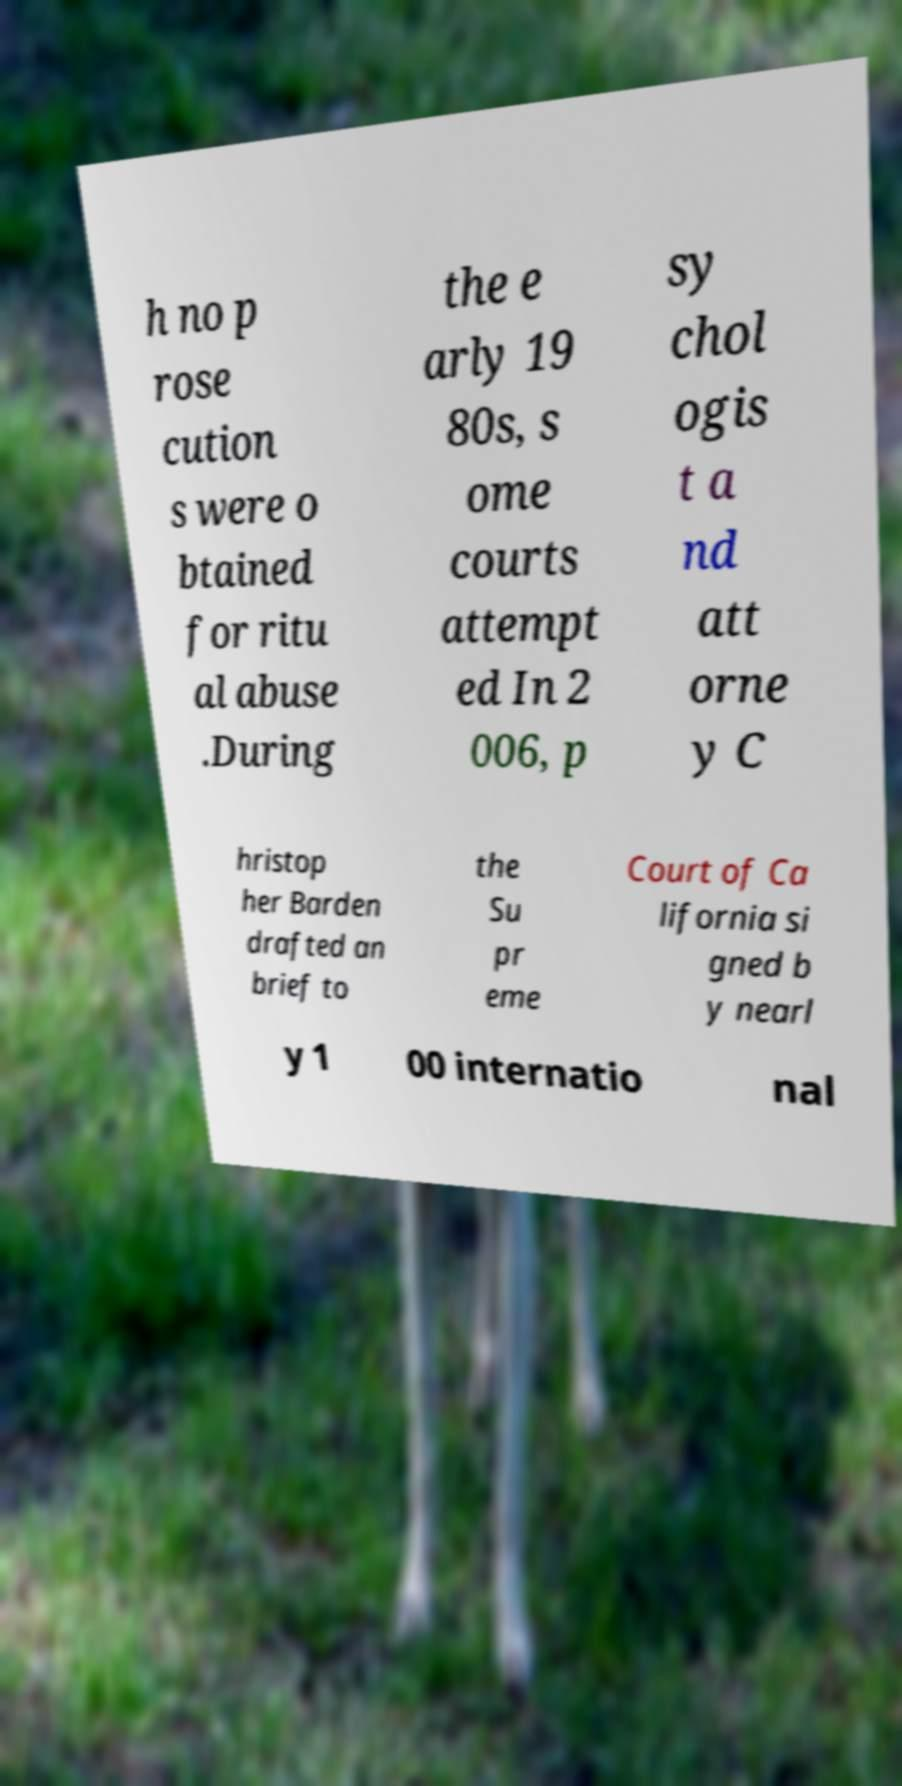Please read and relay the text visible in this image. What does it say? h no p rose cution s were o btained for ritu al abuse .During the e arly 19 80s, s ome courts attempt ed In 2 006, p sy chol ogis t a nd att orne y C hristop her Barden drafted an brief to the Su pr eme Court of Ca lifornia si gned b y nearl y 1 00 internatio nal 